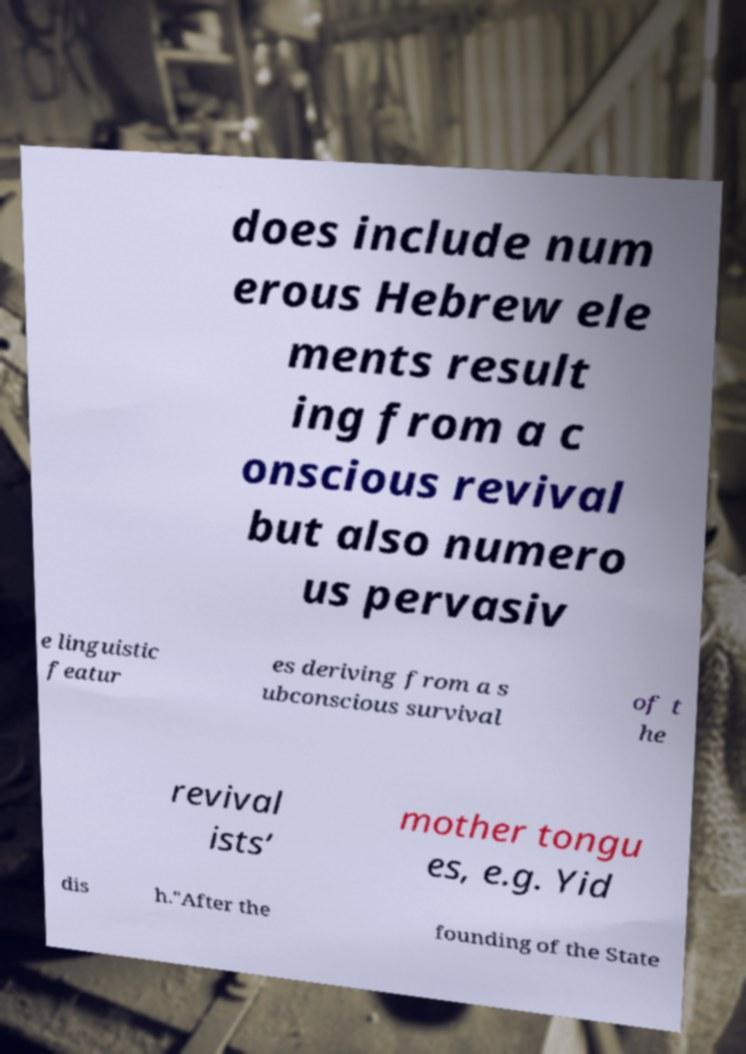What messages or text are displayed in this image? I need them in a readable, typed format. does include num erous Hebrew ele ments result ing from a c onscious revival but also numero us pervasiv e linguistic featur es deriving from a s ubconscious survival of t he revival ists’ mother tongu es, e.g. Yid dis h."After the founding of the State 